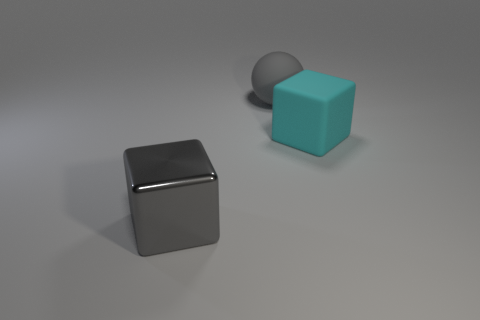Is there anything else that has the same material as the gray cube?
Keep it short and to the point. No. There is a large block left of the large gray thing that is right of the big gray block; are there any big objects that are on the right side of it?
Offer a terse response. Yes. There is a cyan matte thing that is the same size as the gray rubber ball; what is its shape?
Make the answer very short. Cube. The other thing that is the same shape as the large cyan thing is what color?
Give a very brief answer. Gray. What number of things are small rubber cylinders or matte objects?
Your response must be concise. 2. Do the large gray thing that is behind the shiny thing and the big gray object that is in front of the big cyan matte thing have the same shape?
Ensure brevity in your answer.  No. The matte object that is to the left of the cyan thing has what shape?
Your answer should be compact. Sphere. Are there the same number of big cyan objects right of the gray matte thing and blocks that are in front of the big cyan thing?
Keep it short and to the point. Yes. What number of objects are either large gray metallic things or large things behind the large gray shiny object?
Provide a succinct answer. 3. What is the shape of the object that is left of the big cyan cube and in front of the large rubber sphere?
Offer a terse response. Cube. 